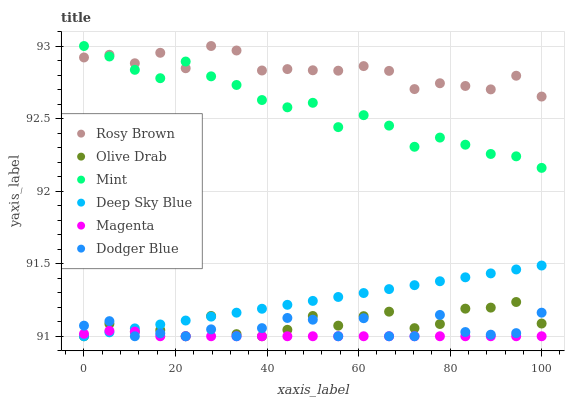Does Magenta have the minimum area under the curve?
Answer yes or no. Yes. Does Rosy Brown have the maximum area under the curve?
Answer yes or no. Yes. Does Dodger Blue have the minimum area under the curve?
Answer yes or no. No. Does Dodger Blue have the maximum area under the curve?
Answer yes or no. No. Is Deep Sky Blue the smoothest?
Answer yes or no. Yes. Is Dodger Blue the roughest?
Answer yes or no. Yes. Is Dodger Blue the smoothest?
Answer yes or no. No. Is Deep Sky Blue the roughest?
Answer yes or no. No. Does Dodger Blue have the lowest value?
Answer yes or no. Yes. Does Mint have the lowest value?
Answer yes or no. No. Does Mint have the highest value?
Answer yes or no. Yes. Does Dodger Blue have the highest value?
Answer yes or no. No. Is Dodger Blue less than Rosy Brown?
Answer yes or no. Yes. Is Rosy Brown greater than Magenta?
Answer yes or no. Yes. Does Magenta intersect Dodger Blue?
Answer yes or no. Yes. Is Magenta less than Dodger Blue?
Answer yes or no. No. Is Magenta greater than Dodger Blue?
Answer yes or no. No. Does Dodger Blue intersect Rosy Brown?
Answer yes or no. No. 